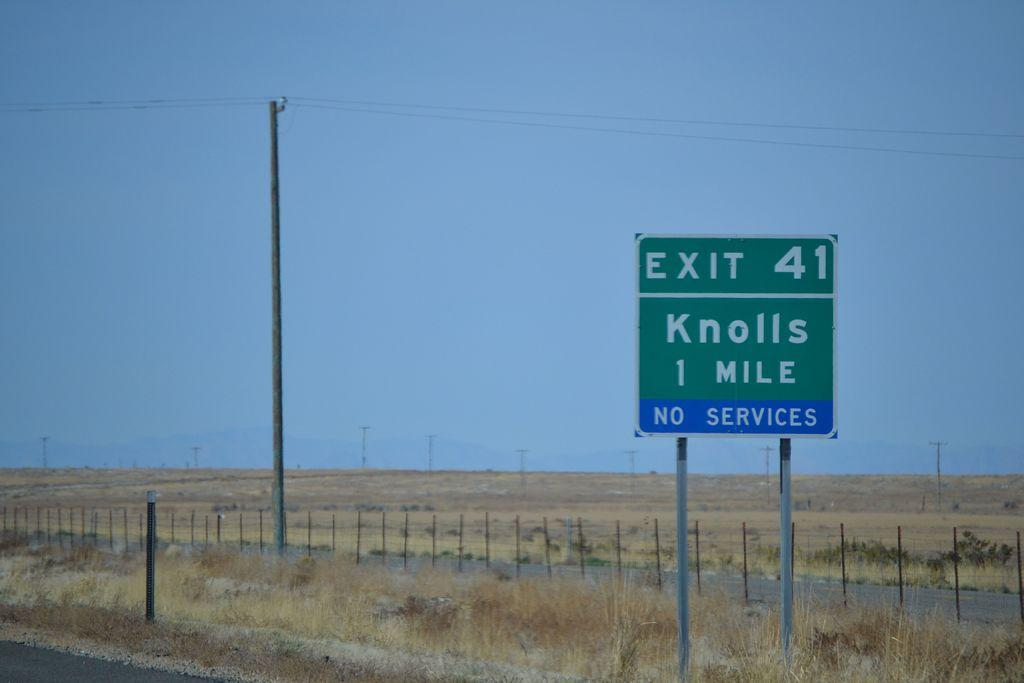<image>
Give a short and clear explanation of the subsequent image. the word knolls on the green sign outside 